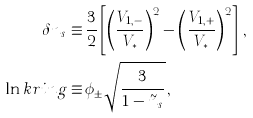Convert formula to latex. <formula><loc_0><loc_0><loc_500><loc_500>\delta { n } _ { s } \equiv & \, \frac { 3 } { 2 } \left [ \left ( \frac { V _ { 1 , - } } { V _ { * } } \right ) ^ { 2 } - \left ( \frac { V _ { 1 , + } } { V _ { * } } \right ) ^ { 2 } \right ] \, , \\ \ln k r i n g \equiv & \, \phi _ { \pm } \sqrt { \frac { 3 } { 1 - \tilde { n } _ { s } } } \, ,</formula> 